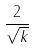Convert formula to latex. <formula><loc_0><loc_0><loc_500><loc_500>\frac { 2 } { \sqrt { k } }</formula> 